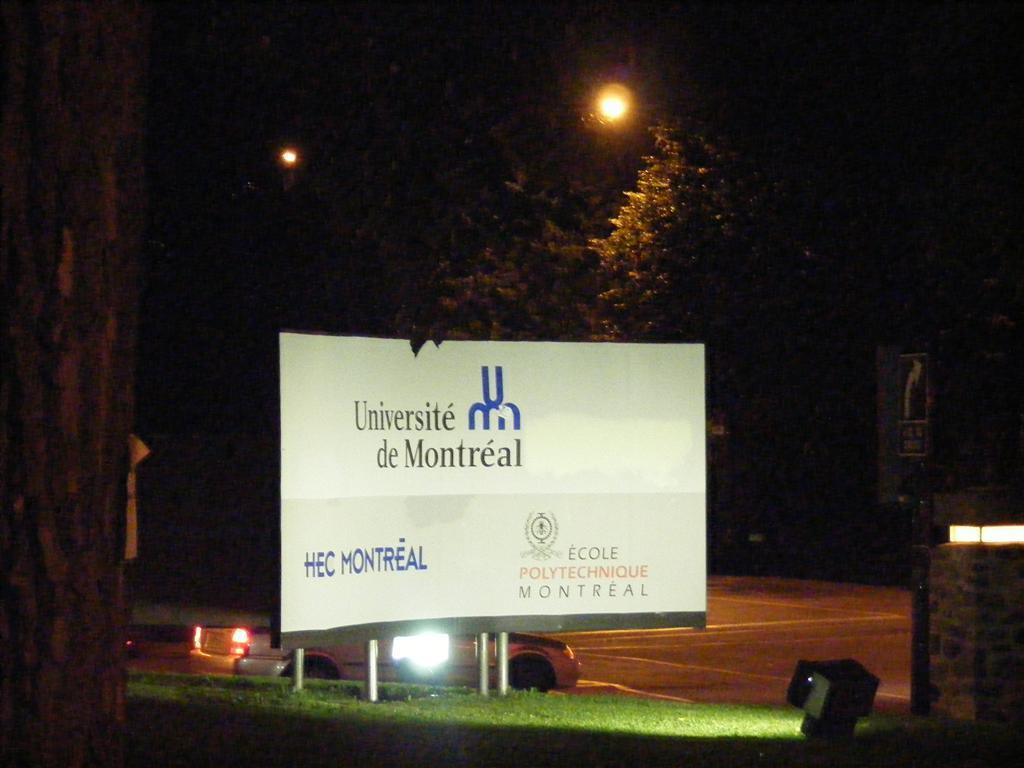<image>
Relay a brief, clear account of the picture shown. A white sign reads Universite de Montreal and is lit at night. 